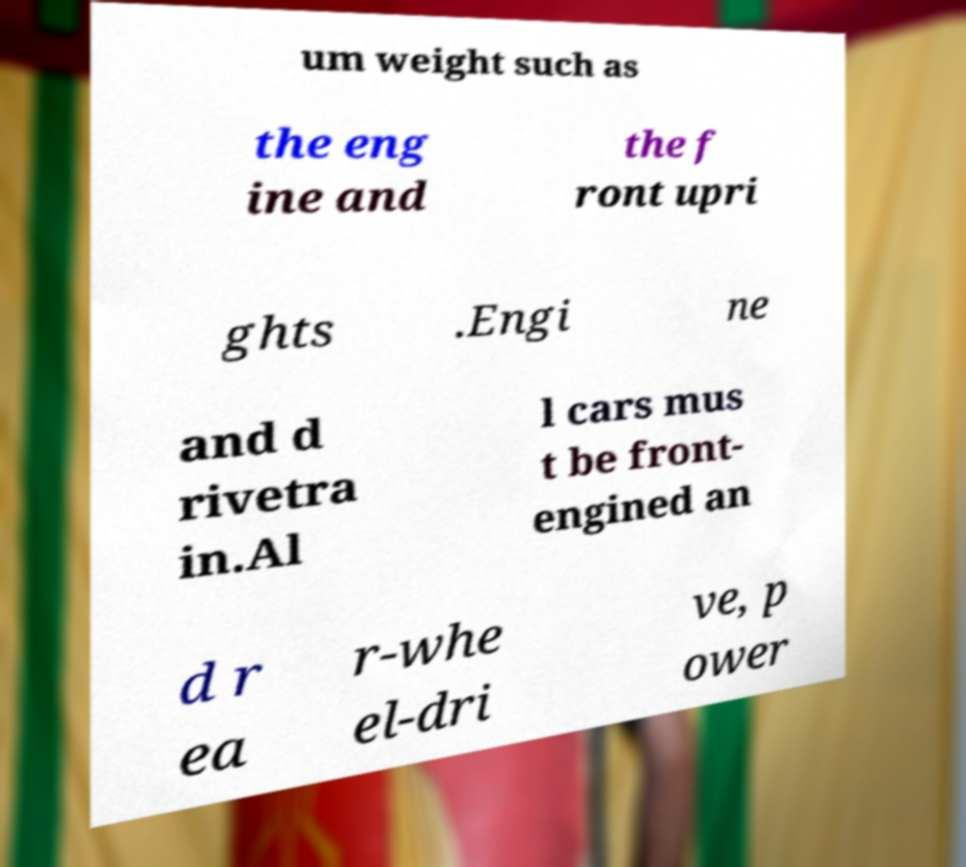Can you read and provide the text displayed in the image?This photo seems to have some interesting text. Can you extract and type it out for me? um weight such as the eng ine and the f ront upri ghts .Engi ne and d rivetra in.Al l cars mus t be front- engined an d r ea r-whe el-dri ve, p ower 